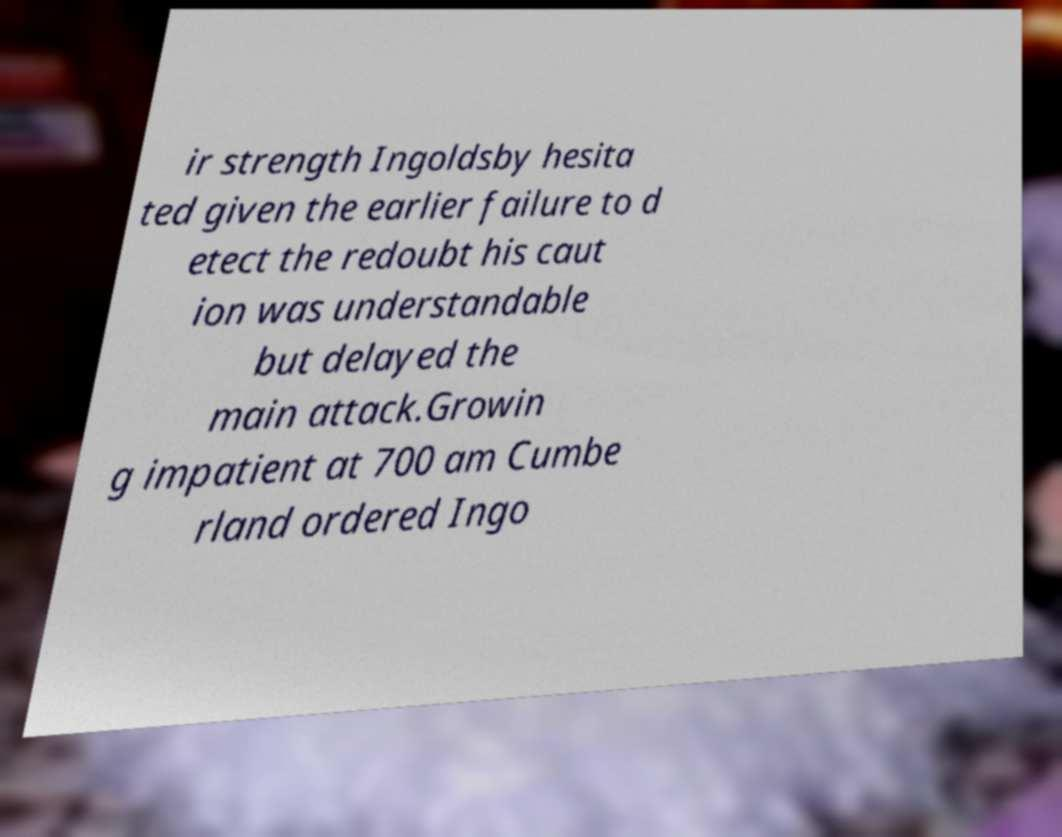Can you accurately transcribe the text from the provided image for me? ir strength Ingoldsby hesita ted given the earlier failure to d etect the redoubt his caut ion was understandable but delayed the main attack.Growin g impatient at 700 am Cumbe rland ordered Ingo 